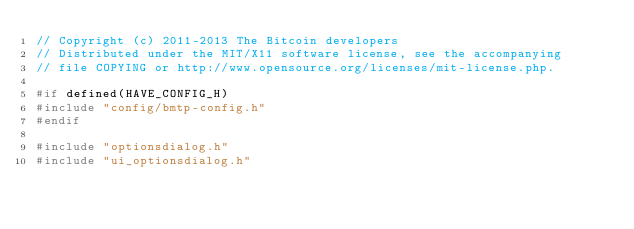<code> <loc_0><loc_0><loc_500><loc_500><_C++_>// Copyright (c) 2011-2013 The Bitcoin developers
// Distributed under the MIT/X11 software license, see the accompanying
// file COPYING or http://www.opensource.org/licenses/mit-license.php.

#if defined(HAVE_CONFIG_H)
#include "config/bmtp-config.h"
#endif

#include "optionsdialog.h"
#include "ui_optionsdialog.h"
</code> 